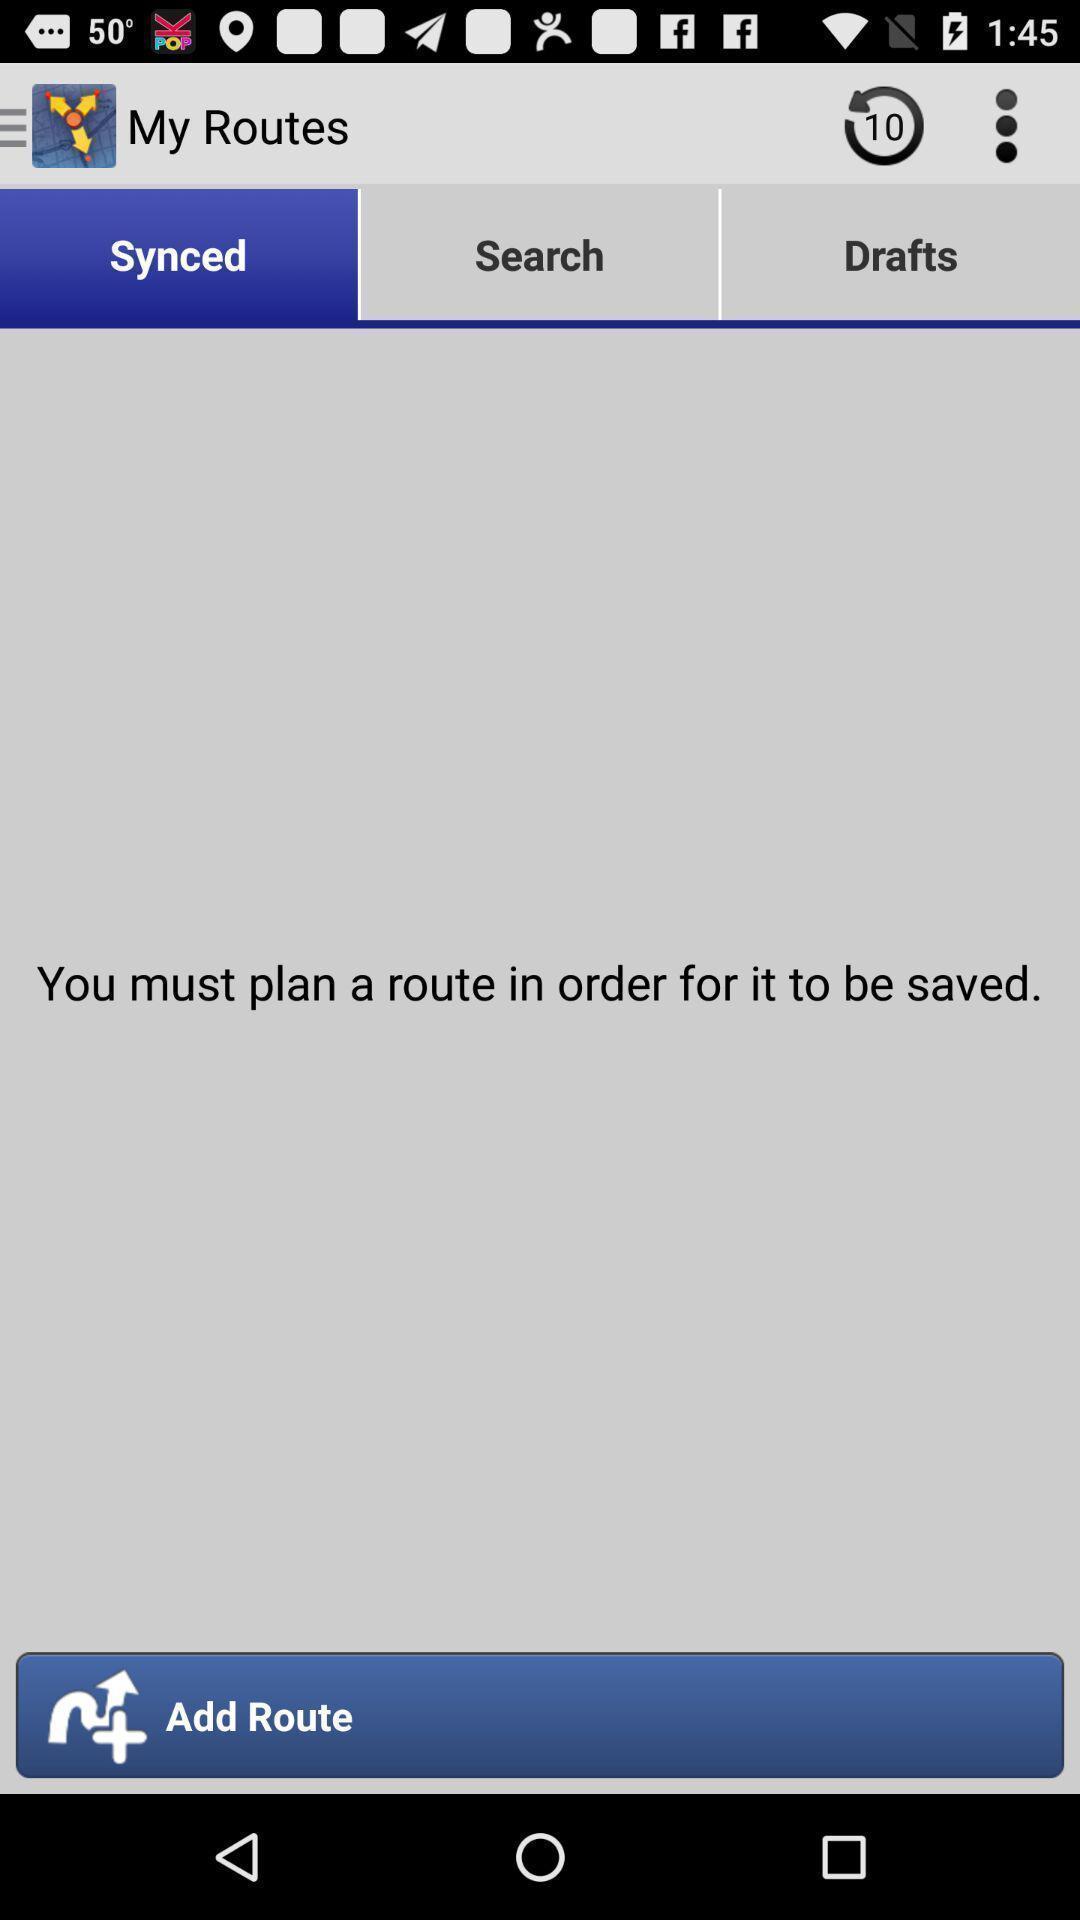Tell me about the visual elements in this screen capture. Screen displaying multiple options in a navigation application. 